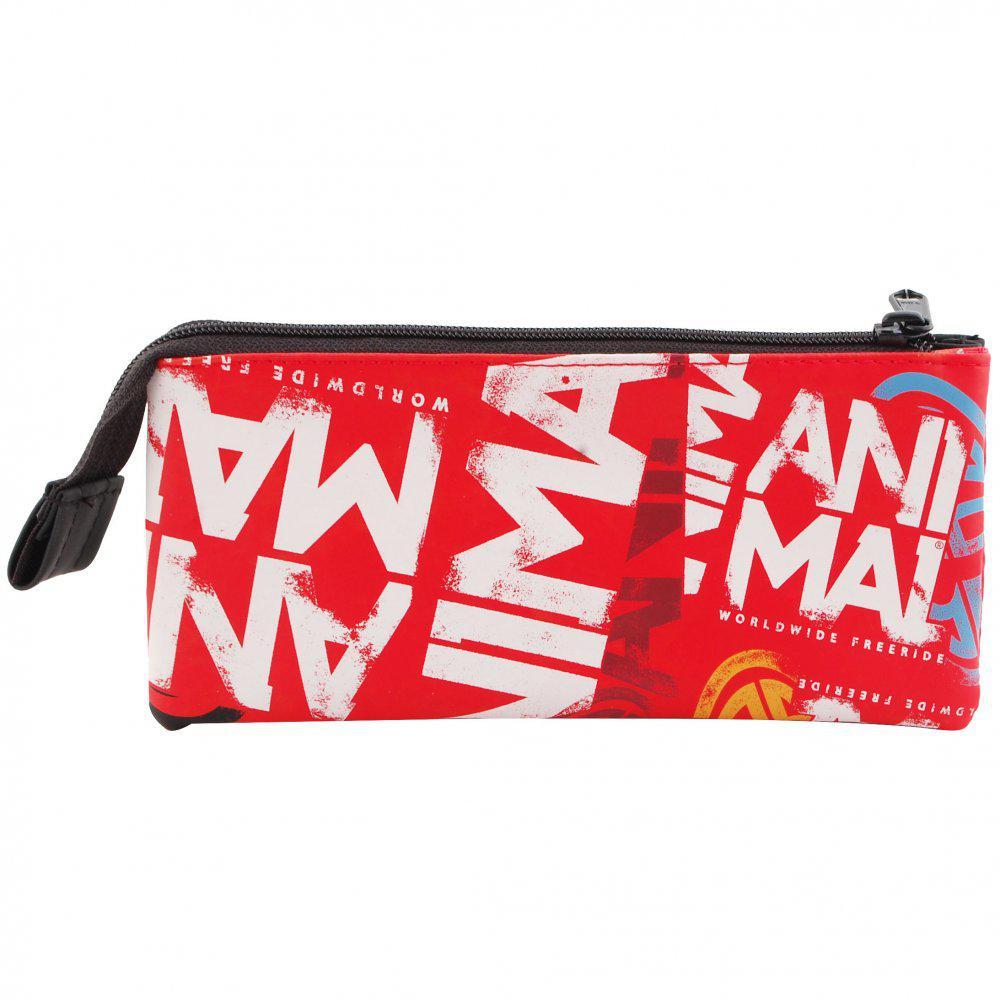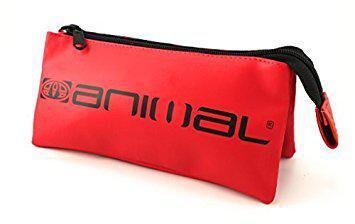The first image is the image on the left, the second image is the image on the right. Evaluate the accuracy of this statement regarding the images: "Two rectangular shaped closed bags are decorated with different designs, but both have a visible zipper pull at one end and the zipper tag hanging down on the other end.". Is it true? Answer yes or no. Yes. The first image is the image on the left, the second image is the image on the right. Assess this claim about the two images: "At least one of the pencil cases is red, and all pencil cases with a visible front feature bold lettering.". Correct or not? Answer yes or no. Yes. 